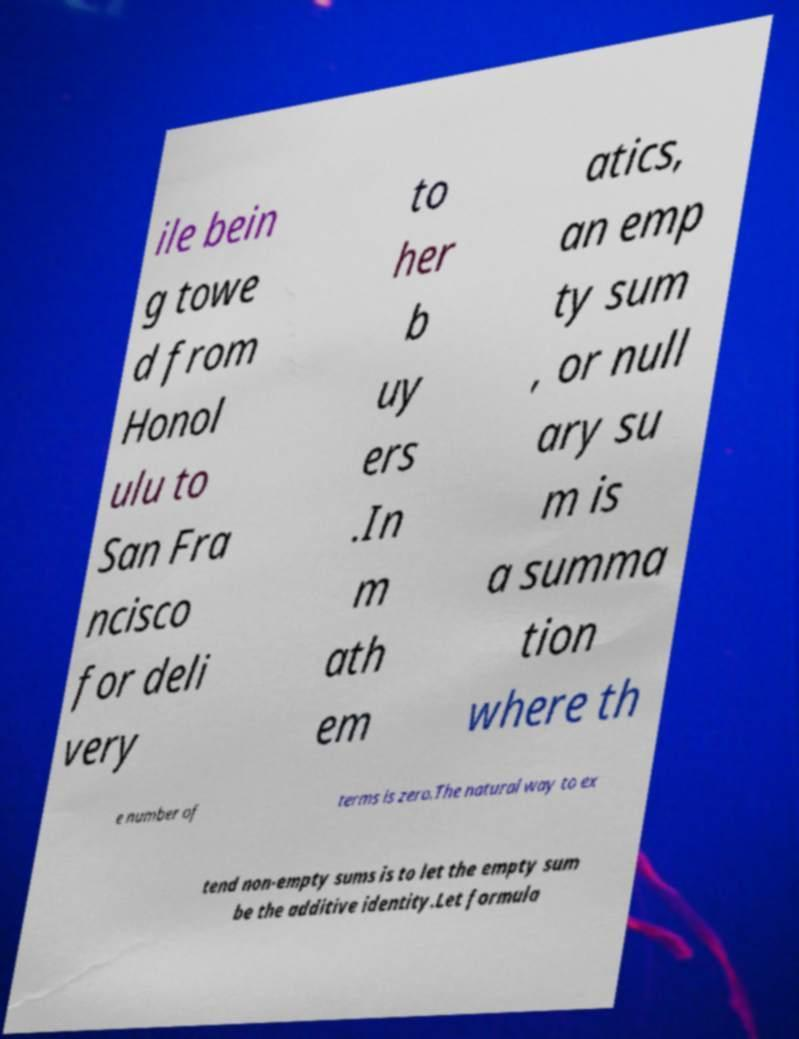I need the written content from this picture converted into text. Can you do that? ile bein g towe d from Honol ulu to San Fra ncisco for deli very to her b uy ers .In m ath em atics, an emp ty sum , or null ary su m is a summa tion where th e number of terms is zero.The natural way to ex tend non-empty sums is to let the empty sum be the additive identity.Let formula 